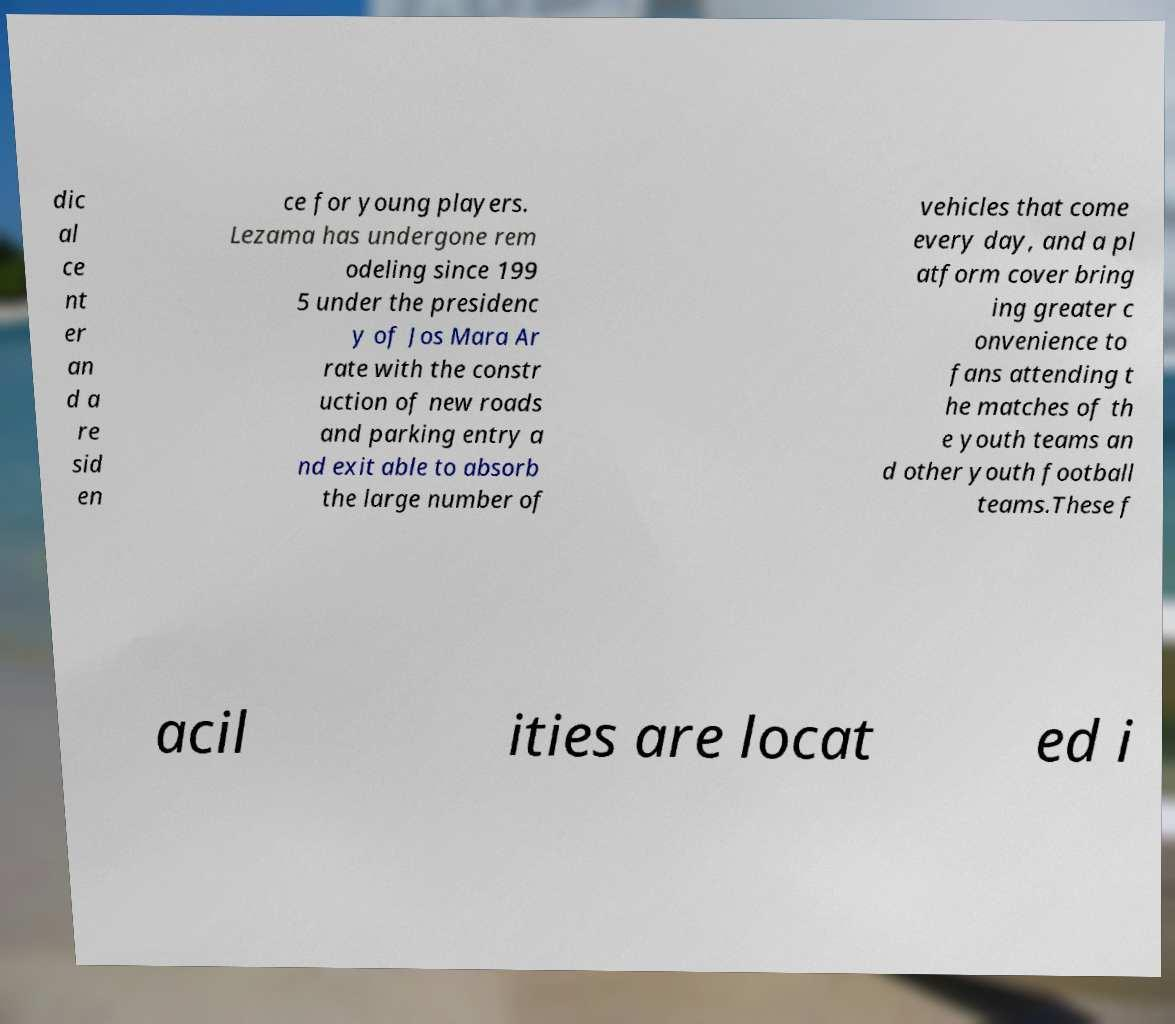Can you read and provide the text displayed in the image?This photo seems to have some interesting text. Can you extract and type it out for me? dic al ce nt er an d a re sid en ce for young players. Lezama has undergone rem odeling since 199 5 under the presidenc y of Jos Mara Ar rate with the constr uction of new roads and parking entry a nd exit able to absorb the large number of vehicles that come every day, and a pl atform cover bring ing greater c onvenience to fans attending t he matches of th e youth teams an d other youth football teams.These f acil ities are locat ed i 